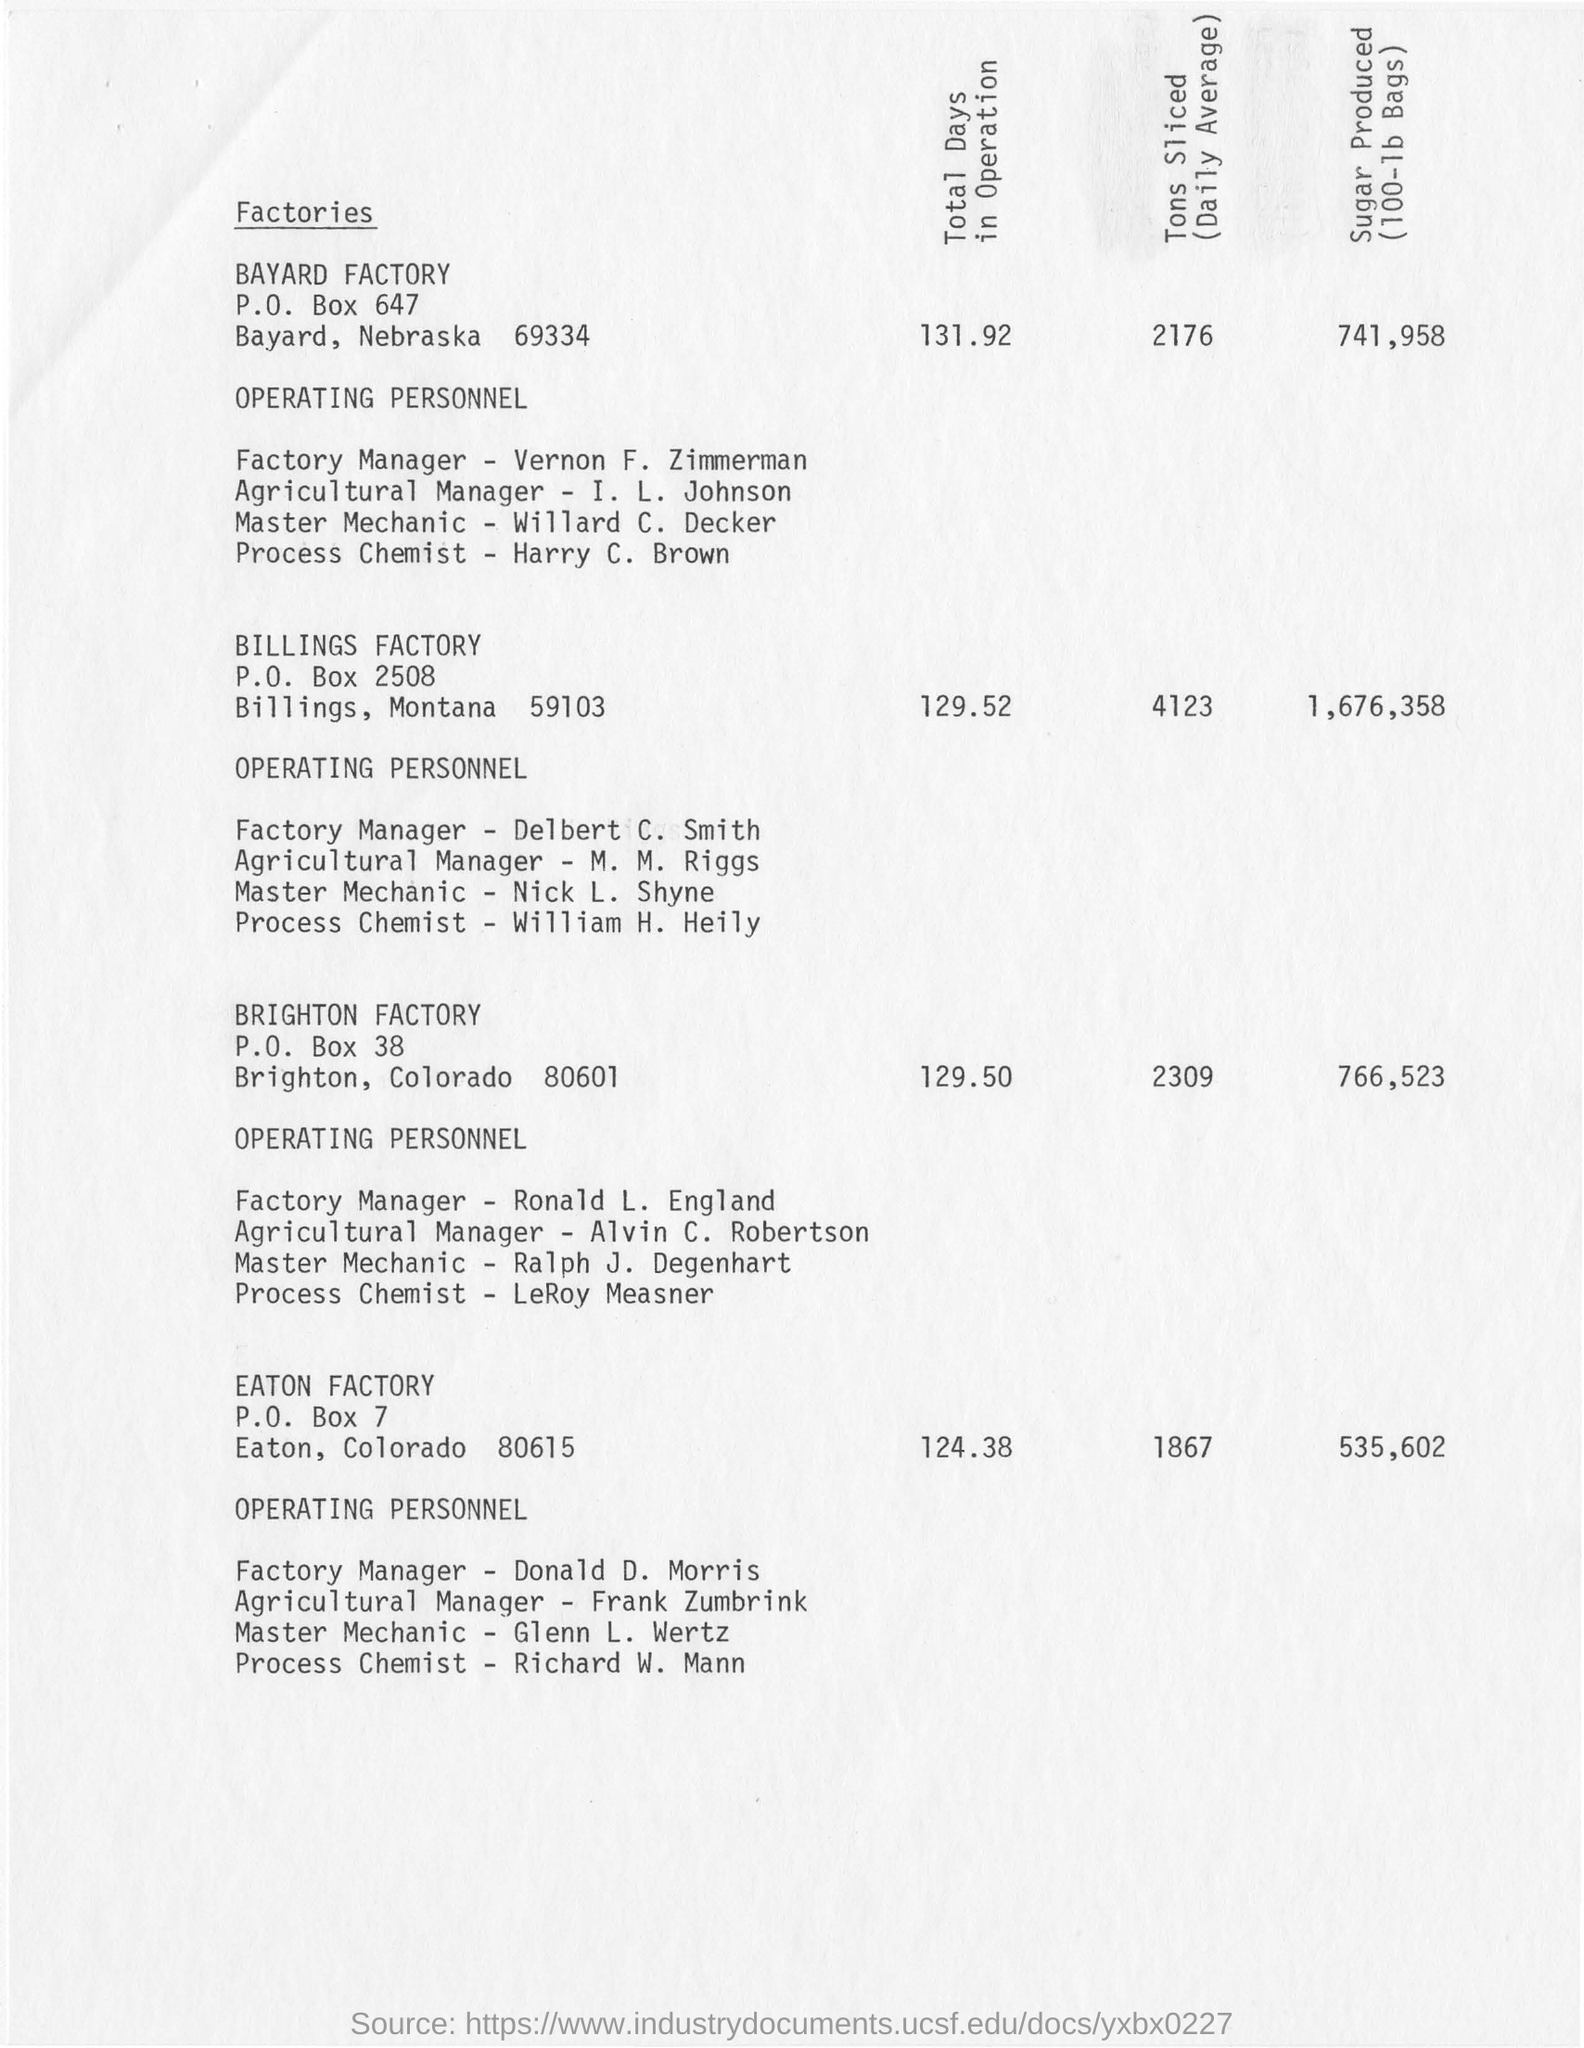Who is the factory manager of Eaton Factory?
Your answer should be compact. Donald  D. Morris. What are the total days in operation for the Brighton factory?
Ensure brevity in your answer.  129.50. Where is the Eaton Factory located?
Provide a succinct answer. Eaton, Colorado. How many tons are sliced at Billings factory on an average?
Give a very brief answer. 4123. 